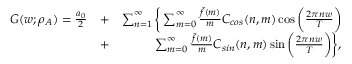Convert formula to latex. <formula><loc_0><loc_0><loc_500><loc_500>\begin{array} { r l r } { G ( w ; \rho _ { A } ) = \frac { a _ { 0 } } { 2 } } & { + } & { \sum _ { n = 1 } ^ { \infty } \left \{ \sum _ { m = 0 } ^ { \infty } \frac { \tilde { f } ( m ) } { m } C _ { \cos } ( n , m ) \cos { \left ( \frac { 2 \pi n w } { T } \right ) } } \\ & { + } & { \sum _ { m = 0 } ^ { \infty } \frac { \tilde { f } ( m ) } { m } C _ { \sin } ( n , m ) \sin { \left ( \frac { 2 \pi n w } { T } \right ) } \right \} , } \end{array}</formula> 